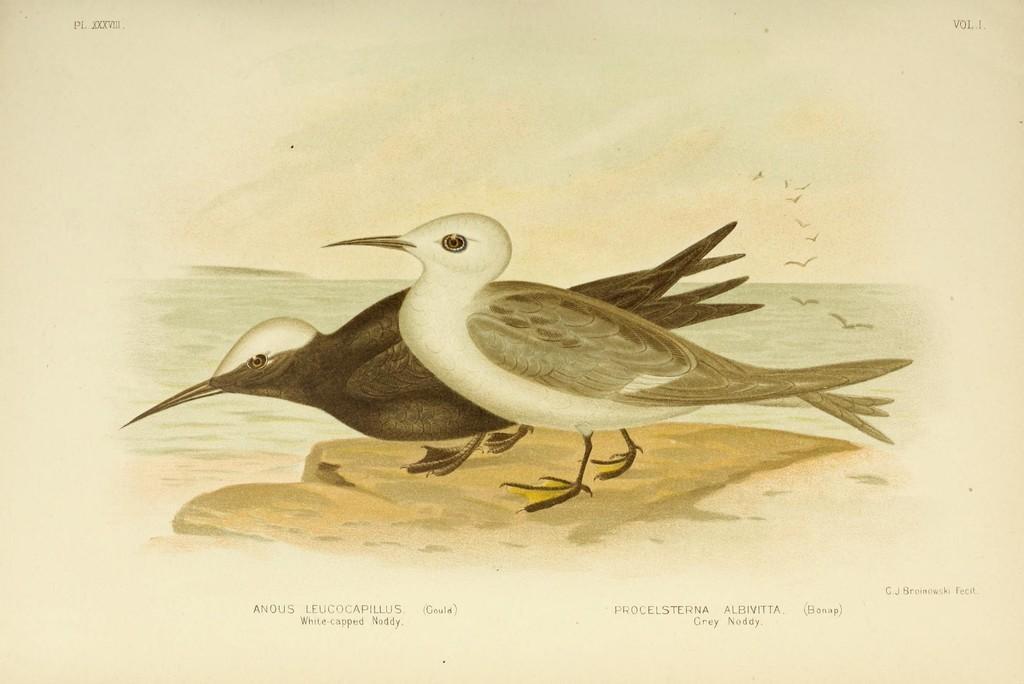In one or two sentences, can you explain what this image depicts? In the picture we can see two birds are standing on the surface, one is white in color and one is black in color and near the birds we can see water and in the air we can see some birds are flying. 